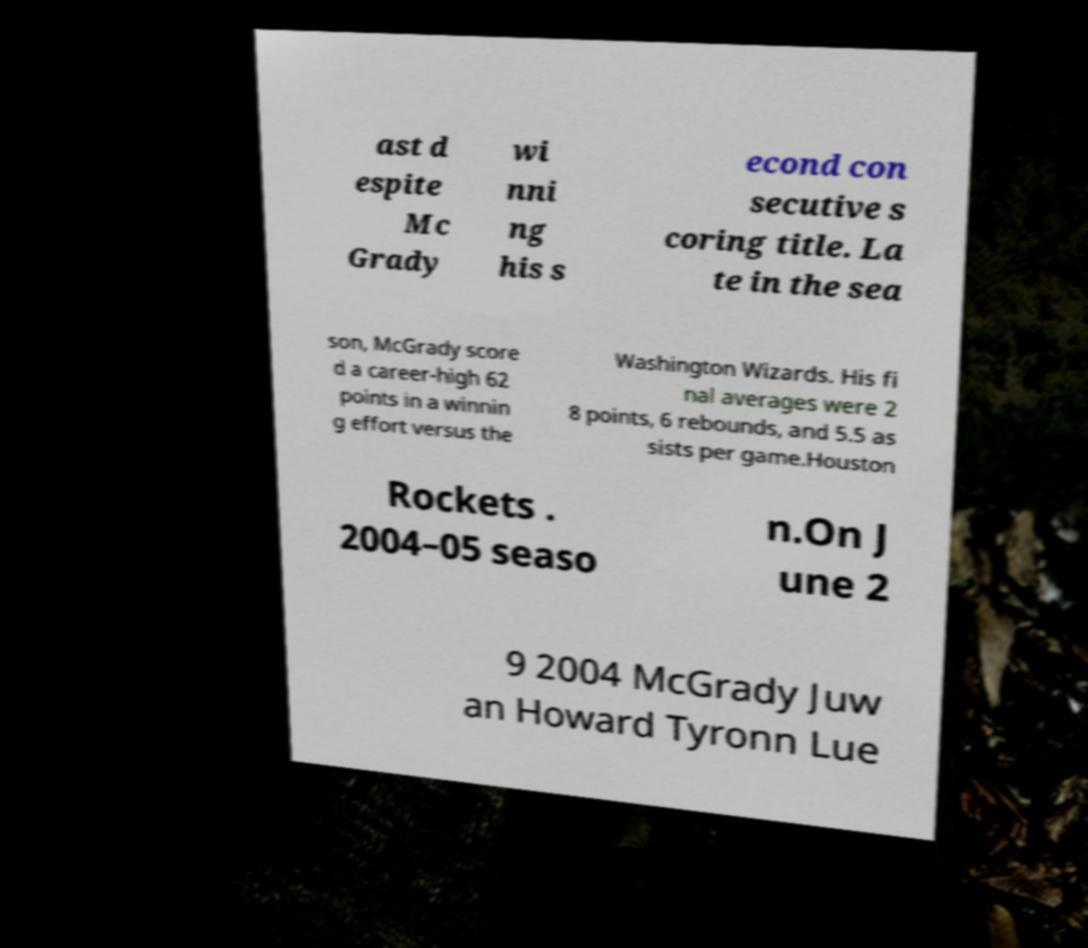Can you accurately transcribe the text from the provided image for me? ast d espite Mc Grady wi nni ng his s econd con secutive s coring title. La te in the sea son, McGrady score d a career-high 62 points in a winnin g effort versus the Washington Wizards. His fi nal averages were 2 8 points, 6 rebounds, and 5.5 as sists per game.Houston Rockets . 2004–05 seaso n.On J une 2 9 2004 McGrady Juw an Howard Tyronn Lue 